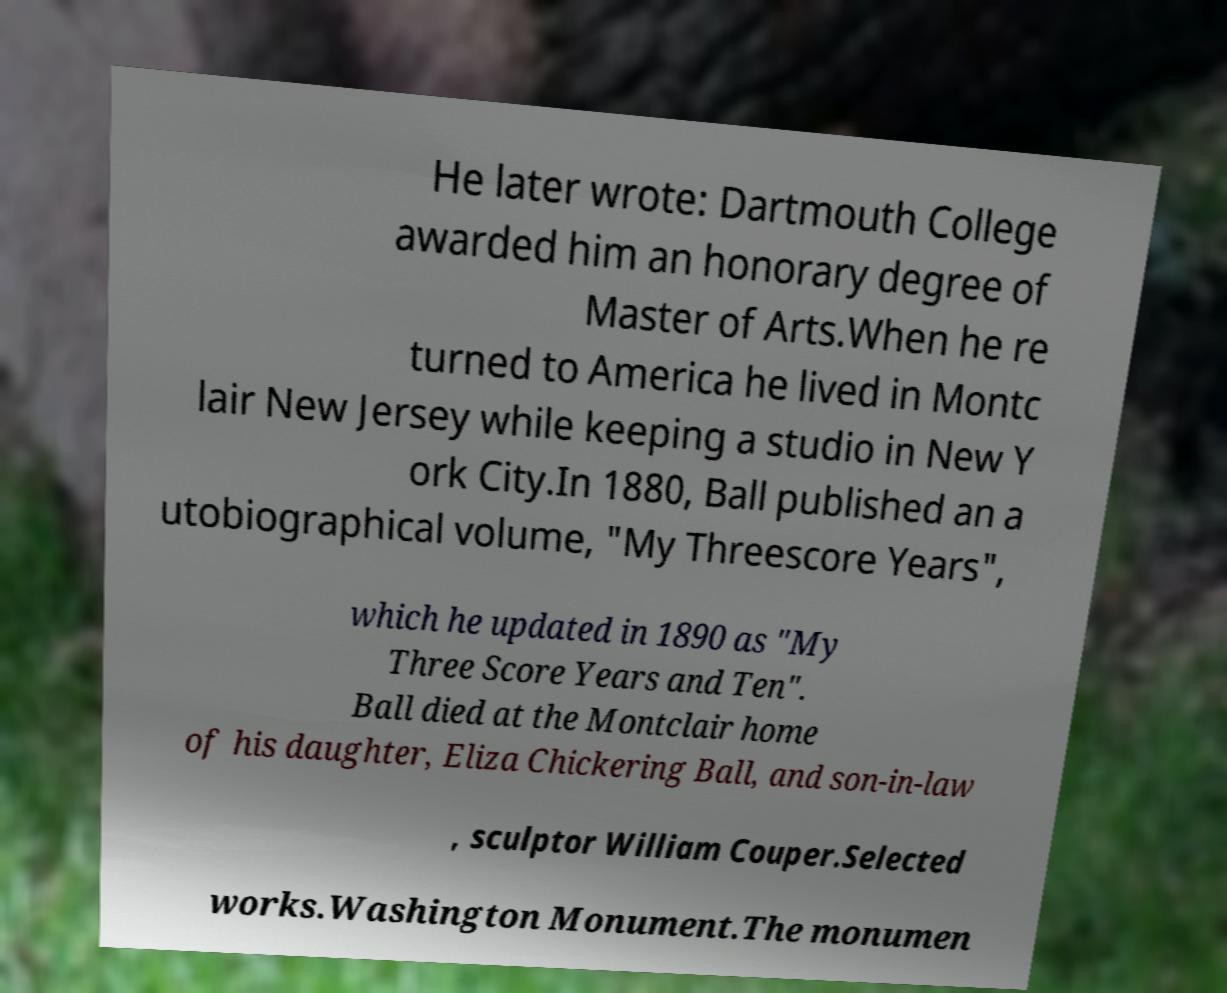Can you accurately transcribe the text from the provided image for me? He later wrote: Dartmouth College awarded him an honorary degree of Master of Arts.When he re turned to America he lived in Montc lair New Jersey while keeping a studio in New Y ork City.In 1880, Ball published an a utobiographical volume, "My Threescore Years", which he updated in 1890 as "My Three Score Years and Ten". Ball died at the Montclair home of his daughter, Eliza Chickering Ball, and son-in-law , sculptor William Couper.Selected works.Washington Monument.The monumen 